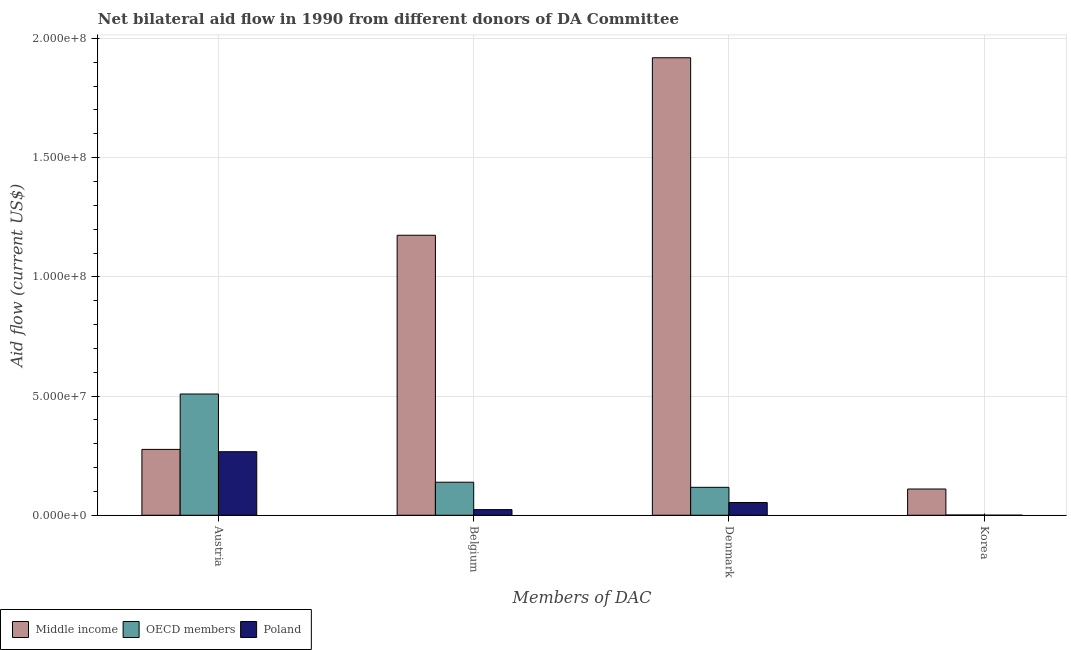How many groups of bars are there?
Give a very brief answer. 4. Are the number of bars on each tick of the X-axis equal?
Give a very brief answer. Yes. How many bars are there on the 4th tick from the left?
Make the answer very short. 3. How many bars are there on the 3rd tick from the right?
Keep it short and to the point. 3. What is the label of the 3rd group of bars from the left?
Provide a short and direct response. Denmark. What is the amount of aid given by austria in Middle income?
Keep it short and to the point. 2.76e+07. Across all countries, what is the maximum amount of aid given by denmark?
Ensure brevity in your answer.  1.92e+08. Across all countries, what is the minimum amount of aid given by belgium?
Offer a very short reply. 2.37e+06. What is the total amount of aid given by belgium in the graph?
Offer a very short reply. 1.34e+08. What is the difference between the amount of aid given by korea in Poland and that in Middle income?
Provide a succinct answer. -1.10e+07. What is the difference between the amount of aid given by denmark in Poland and the amount of aid given by austria in Middle income?
Your response must be concise. -2.23e+07. What is the average amount of aid given by korea per country?
Keep it short and to the point. 3.72e+06. What is the difference between the amount of aid given by korea and amount of aid given by belgium in OECD members?
Keep it short and to the point. -1.38e+07. In how many countries, is the amount of aid given by denmark greater than 30000000 US$?
Provide a succinct answer. 1. What is the ratio of the amount of aid given by denmark in Poland to that in Middle income?
Offer a very short reply. 0.03. Is the difference between the amount of aid given by korea in Middle income and OECD members greater than the difference between the amount of aid given by austria in Middle income and OECD members?
Your answer should be very brief. Yes. What is the difference between the highest and the second highest amount of aid given by denmark?
Your answer should be compact. 1.80e+08. What is the difference between the highest and the lowest amount of aid given by austria?
Your response must be concise. 2.42e+07. Is it the case that in every country, the sum of the amount of aid given by belgium and amount of aid given by denmark is greater than the sum of amount of aid given by austria and amount of aid given by korea?
Give a very brief answer. No. What does the 2nd bar from the left in Belgium represents?
Give a very brief answer. OECD members. What does the 2nd bar from the right in Belgium represents?
Make the answer very short. OECD members. Is it the case that in every country, the sum of the amount of aid given by austria and amount of aid given by belgium is greater than the amount of aid given by denmark?
Your answer should be compact. No. How many bars are there?
Provide a short and direct response. 12. How many countries are there in the graph?
Your answer should be very brief. 3. What is the difference between two consecutive major ticks on the Y-axis?
Make the answer very short. 5.00e+07. Are the values on the major ticks of Y-axis written in scientific E-notation?
Your response must be concise. Yes. Does the graph contain grids?
Keep it short and to the point. Yes. How many legend labels are there?
Ensure brevity in your answer.  3. What is the title of the graph?
Provide a succinct answer. Net bilateral aid flow in 1990 from different donors of DA Committee. What is the label or title of the X-axis?
Your answer should be very brief. Members of DAC. What is the label or title of the Y-axis?
Provide a succinct answer. Aid flow (current US$). What is the Aid flow (current US$) in Middle income in Austria?
Your response must be concise. 2.76e+07. What is the Aid flow (current US$) of OECD members in Austria?
Offer a terse response. 5.09e+07. What is the Aid flow (current US$) of Poland in Austria?
Offer a very short reply. 2.67e+07. What is the Aid flow (current US$) of Middle income in Belgium?
Your answer should be very brief. 1.17e+08. What is the Aid flow (current US$) of OECD members in Belgium?
Keep it short and to the point. 1.39e+07. What is the Aid flow (current US$) of Poland in Belgium?
Give a very brief answer. 2.37e+06. What is the Aid flow (current US$) of Middle income in Denmark?
Ensure brevity in your answer.  1.92e+08. What is the Aid flow (current US$) in OECD members in Denmark?
Make the answer very short. 1.17e+07. What is the Aid flow (current US$) in Poland in Denmark?
Provide a succinct answer. 5.34e+06. What is the Aid flow (current US$) in Middle income in Korea?
Give a very brief answer. 1.10e+07. Across all Members of DAC, what is the maximum Aid flow (current US$) of Middle income?
Your answer should be very brief. 1.92e+08. Across all Members of DAC, what is the maximum Aid flow (current US$) in OECD members?
Give a very brief answer. 5.09e+07. Across all Members of DAC, what is the maximum Aid flow (current US$) in Poland?
Provide a succinct answer. 2.67e+07. Across all Members of DAC, what is the minimum Aid flow (current US$) in Middle income?
Offer a terse response. 1.10e+07. Across all Members of DAC, what is the minimum Aid flow (current US$) of OECD members?
Offer a terse response. 1.10e+05. What is the total Aid flow (current US$) in Middle income in the graph?
Your response must be concise. 3.48e+08. What is the total Aid flow (current US$) of OECD members in the graph?
Offer a terse response. 7.66e+07. What is the total Aid flow (current US$) of Poland in the graph?
Your answer should be very brief. 3.44e+07. What is the difference between the Aid flow (current US$) of Middle income in Austria and that in Belgium?
Your answer should be compact. -8.98e+07. What is the difference between the Aid flow (current US$) of OECD members in Austria and that in Belgium?
Keep it short and to the point. 3.70e+07. What is the difference between the Aid flow (current US$) in Poland in Austria and that in Belgium?
Your answer should be very brief. 2.43e+07. What is the difference between the Aid flow (current US$) of Middle income in Austria and that in Denmark?
Your response must be concise. -1.64e+08. What is the difference between the Aid flow (current US$) in OECD members in Austria and that in Denmark?
Make the answer very short. 3.91e+07. What is the difference between the Aid flow (current US$) in Poland in Austria and that in Denmark?
Your answer should be very brief. 2.13e+07. What is the difference between the Aid flow (current US$) of Middle income in Austria and that in Korea?
Offer a terse response. 1.66e+07. What is the difference between the Aid flow (current US$) of OECD members in Austria and that in Korea?
Your answer should be very brief. 5.08e+07. What is the difference between the Aid flow (current US$) in Poland in Austria and that in Korea?
Provide a short and direct response. 2.66e+07. What is the difference between the Aid flow (current US$) of Middle income in Belgium and that in Denmark?
Your answer should be very brief. -7.45e+07. What is the difference between the Aid flow (current US$) in OECD members in Belgium and that in Denmark?
Your response must be concise. 2.14e+06. What is the difference between the Aid flow (current US$) of Poland in Belgium and that in Denmark?
Give a very brief answer. -2.97e+06. What is the difference between the Aid flow (current US$) of Middle income in Belgium and that in Korea?
Offer a terse response. 1.06e+08. What is the difference between the Aid flow (current US$) of OECD members in Belgium and that in Korea?
Make the answer very short. 1.38e+07. What is the difference between the Aid flow (current US$) in Poland in Belgium and that in Korea?
Keep it short and to the point. 2.34e+06. What is the difference between the Aid flow (current US$) in Middle income in Denmark and that in Korea?
Your response must be concise. 1.81e+08. What is the difference between the Aid flow (current US$) in OECD members in Denmark and that in Korea?
Keep it short and to the point. 1.16e+07. What is the difference between the Aid flow (current US$) of Poland in Denmark and that in Korea?
Give a very brief answer. 5.31e+06. What is the difference between the Aid flow (current US$) of Middle income in Austria and the Aid flow (current US$) of OECD members in Belgium?
Offer a very short reply. 1.38e+07. What is the difference between the Aid flow (current US$) in Middle income in Austria and the Aid flow (current US$) in Poland in Belgium?
Provide a succinct answer. 2.53e+07. What is the difference between the Aid flow (current US$) of OECD members in Austria and the Aid flow (current US$) of Poland in Belgium?
Your response must be concise. 4.85e+07. What is the difference between the Aid flow (current US$) of Middle income in Austria and the Aid flow (current US$) of OECD members in Denmark?
Give a very brief answer. 1.59e+07. What is the difference between the Aid flow (current US$) of Middle income in Austria and the Aid flow (current US$) of Poland in Denmark?
Offer a terse response. 2.23e+07. What is the difference between the Aid flow (current US$) of OECD members in Austria and the Aid flow (current US$) of Poland in Denmark?
Keep it short and to the point. 4.55e+07. What is the difference between the Aid flow (current US$) of Middle income in Austria and the Aid flow (current US$) of OECD members in Korea?
Ensure brevity in your answer.  2.75e+07. What is the difference between the Aid flow (current US$) in Middle income in Austria and the Aid flow (current US$) in Poland in Korea?
Make the answer very short. 2.76e+07. What is the difference between the Aid flow (current US$) in OECD members in Austria and the Aid flow (current US$) in Poland in Korea?
Offer a terse response. 5.08e+07. What is the difference between the Aid flow (current US$) of Middle income in Belgium and the Aid flow (current US$) of OECD members in Denmark?
Offer a terse response. 1.06e+08. What is the difference between the Aid flow (current US$) in Middle income in Belgium and the Aid flow (current US$) in Poland in Denmark?
Make the answer very short. 1.12e+08. What is the difference between the Aid flow (current US$) in OECD members in Belgium and the Aid flow (current US$) in Poland in Denmark?
Ensure brevity in your answer.  8.52e+06. What is the difference between the Aid flow (current US$) of Middle income in Belgium and the Aid flow (current US$) of OECD members in Korea?
Provide a short and direct response. 1.17e+08. What is the difference between the Aid flow (current US$) in Middle income in Belgium and the Aid flow (current US$) in Poland in Korea?
Provide a short and direct response. 1.17e+08. What is the difference between the Aid flow (current US$) in OECD members in Belgium and the Aid flow (current US$) in Poland in Korea?
Your answer should be very brief. 1.38e+07. What is the difference between the Aid flow (current US$) in Middle income in Denmark and the Aid flow (current US$) in OECD members in Korea?
Provide a succinct answer. 1.92e+08. What is the difference between the Aid flow (current US$) of Middle income in Denmark and the Aid flow (current US$) of Poland in Korea?
Provide a short and direct response. 1.92e+08. What is the difference between the Aid flow (current US$) of OECD members in Denmark and the Aid flow (current US$) of Poland in Korea?
Your answer should be compact. 1.17e+07. What is the average Aid flow (current US$) in Middle income per Members of DAC?
Provide a succinct answer. 8.70e+07. What is the average Aid flow (current US$) in OECD members per Members of DAC?
Make the answer very short. 1.91e+07. What is the average Aid flow (current US$) in Poland per Members of DAC?
Provide a succinct answer. 8.60e+06. What is the difference between the Aid flow (current US$) in Middle income and Aid flow (current US$) in OECD members in Austria?
Your answer should be very brief. -2.32e+07. What is the difference between the Aid flow (current US$) in Middle income and Aid flow (current US$) in Poland in Austria?
Your answer should be very brief. 9.70e+05. What is the difference between the Aid flow (current US$) of OECD members and Aid flow (current US$) of Poland in Austria?
Provide a short and direct response. 2.42e+07. What is the difference between the Aid flow (current US$) in Middle income and Aid flow (current US$) in OECD members in Belgium?
Your response must be concise. 1.04e+08. What is the difference between the Aid flow (current US$) in Middle income and Aid flow (current US$) in Poland in Belgium?
Make the answer very short. 1.15e+08. What is the difference between the Aid flow (current US$) in OECD members and Aid flow (current US$) in Poland in Belgium?
Provide a short and direct response. 1.15e+07. What is the difference between the Aid flow (current US$) in Middle income and Aid flow (current US$) in OECD members in Denmark?
Keep it short and to the point. 1.80e+08. What is the difference between the Aid flow (current US$) of Middle income and Aid flow (current US$) of Poland in Denmark?
Your answer should be very brief. 1.87e+08. What is the difference between the Aid flow (current US$) of OECD members and Aid flow (current US$) of Poland in Denmark?
Give a very brief answer. 6.38e+06. What is the difference between the Aid flow (current US$) of Middle income and Aid flow (current US$) of OECD members in Korea?
Make the answer very short. 1.09e+07. What is the difference between the Aid flow (current US$) in Middle income and Aid flow (current US$) in Poland in Korea?
Provide a short and direct response. 1.10e+07. What is the difference between the Aid flow (current US$) of OECD members and Aid flow (current US$) of Poland in Korea?
Provide a succinct answer. 8.00e+04. What is the ratio of the Aid flow (current US$) of Middle income in Austria to that in Belgium?
Keep it short and to the point. 0.24. What is the ratio of the Aid flow (current US$) of OECD members in Austria to that in Belgium?
Offer a very short reply. 3.67. What is the ratio of the Aid flow (current US$) in Poland in Austria to that in Belgium?
Provide a short and direct response. 11.25. What is the ratio of the Aid flow (current US$) of Middle income in Austria to that in Denmark?
Provide a succinct answer. 0.14. What is the ratio of the Aid flow (current US$) of OECD members in Austria to that in Denmark?
Provide a succinct answer. 4.34. What is the ratio of the Aid flow (current US$) of Poland in Austria to that in Denmark?
Give a very brief answer. 4.99. What is the ratio of the Aid flow (current US$) in Middle income in Austria to that in Korea?
Give a very brief answer. 2.51. What is the ratio of the Aid flow (current US$) in OECD members in Austria to that in Korea?
Offer a very short reply. 462.36. What is the ratio of the Aid flow (current US$) of Poland in Austria to that in Korea?
Keep it short and to the point. 888.67. What is the ratio of the Aid flow (current US$) in Middle income in Belgium to that in Denmark?
Keep it short and to the point. 0.61. What is the ratio of the Aid flow (current US$) in OECD members in Belgium to that in Denmark?
Your response must be concise. 1.18. What is the ratio of the Aid flow (current US$) of Poland in Belgium to that in Denmark?
Give a very brief answer. 0.44. What is the ratio of the Aid flow (current US$) of Middle income in Belgium to that in Korea?
Ensure brevity in your answer.  10.67. What is the ratio of the Aid flow (current US$) of OECD members in Belgium to that in Korea?
Provide a short and direct response. 126. What is the ratio of the Aid flow (current US$) of Poland in Belgium to that in Korea?
Keep it short and to the point. 79. What is the ratio of the Aid flow (current US$) in Middle income in Denmark to that in Korea?
Offer a terse response. 17.43. What is the ratio of the Aid flow (current US$) of OECD members in Denmark to that in Korea?
Offer a very short reply. 106.55. What is the ratio of the Aid flow (current US$) of Poland in Denmark to that in Korea?
Provide a succinct answer. 178. What is the difference between the highest and the second highest Aid flow (current US$) of Middle income?
Provide a succinct answer. 7.45e+07. What is the difference between the highest and the second highest Aid flow (current US$) in OECD members?
Your answer should be very brief. 3.70e+07. What is the difference between the highest and the second highest Aid flow (current US$) in Poland?
Your answer should be compact. 2.13e+07. What is the difference between the highest and the lowest Aid flow (current US$) of Middle income?
Keep it short and to the point. 1.81e+08. What is the difference between the highest and the lowest Aid flow (current US$) in OECD members?
Provide a short and direct response. 5.08e+07. What is the difference between the highest and the lowest Aid flow (current US$) in Poland?
Make the answer very short. 2.66e+07. 